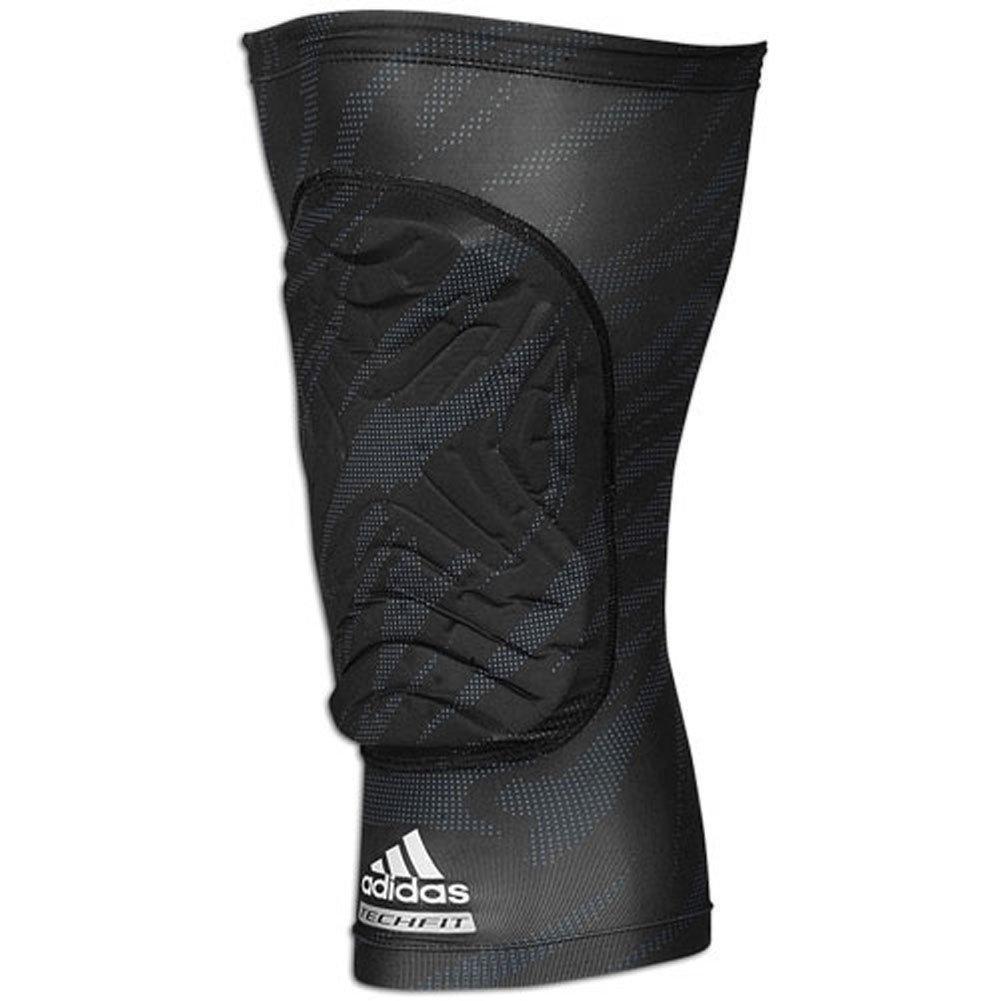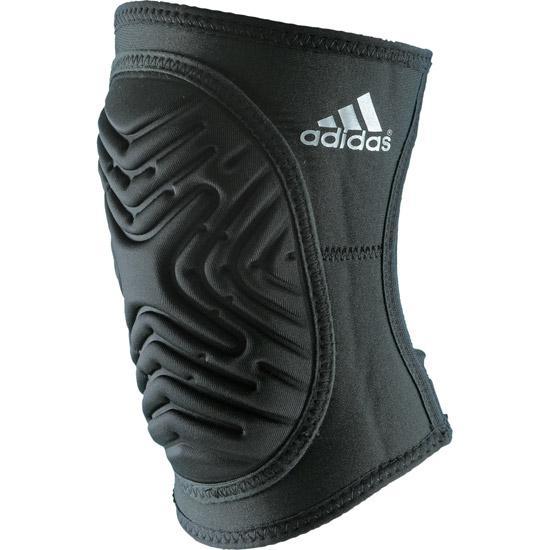The first image is the image on the left, the second image is the image on the right. Examine the images to the left and right. Is the description "The knee pad is turned to the right in the image on the right." accurate? Answer yes or no. No. 